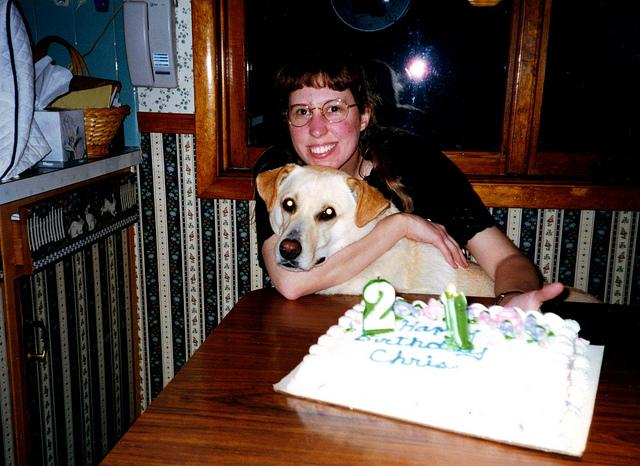Is the dog smiling?
Write a very short answer. No. Whose birthday is it?
Short answer required. Chris. Is this a birthday cake?
Write a very short answer. Yes. 